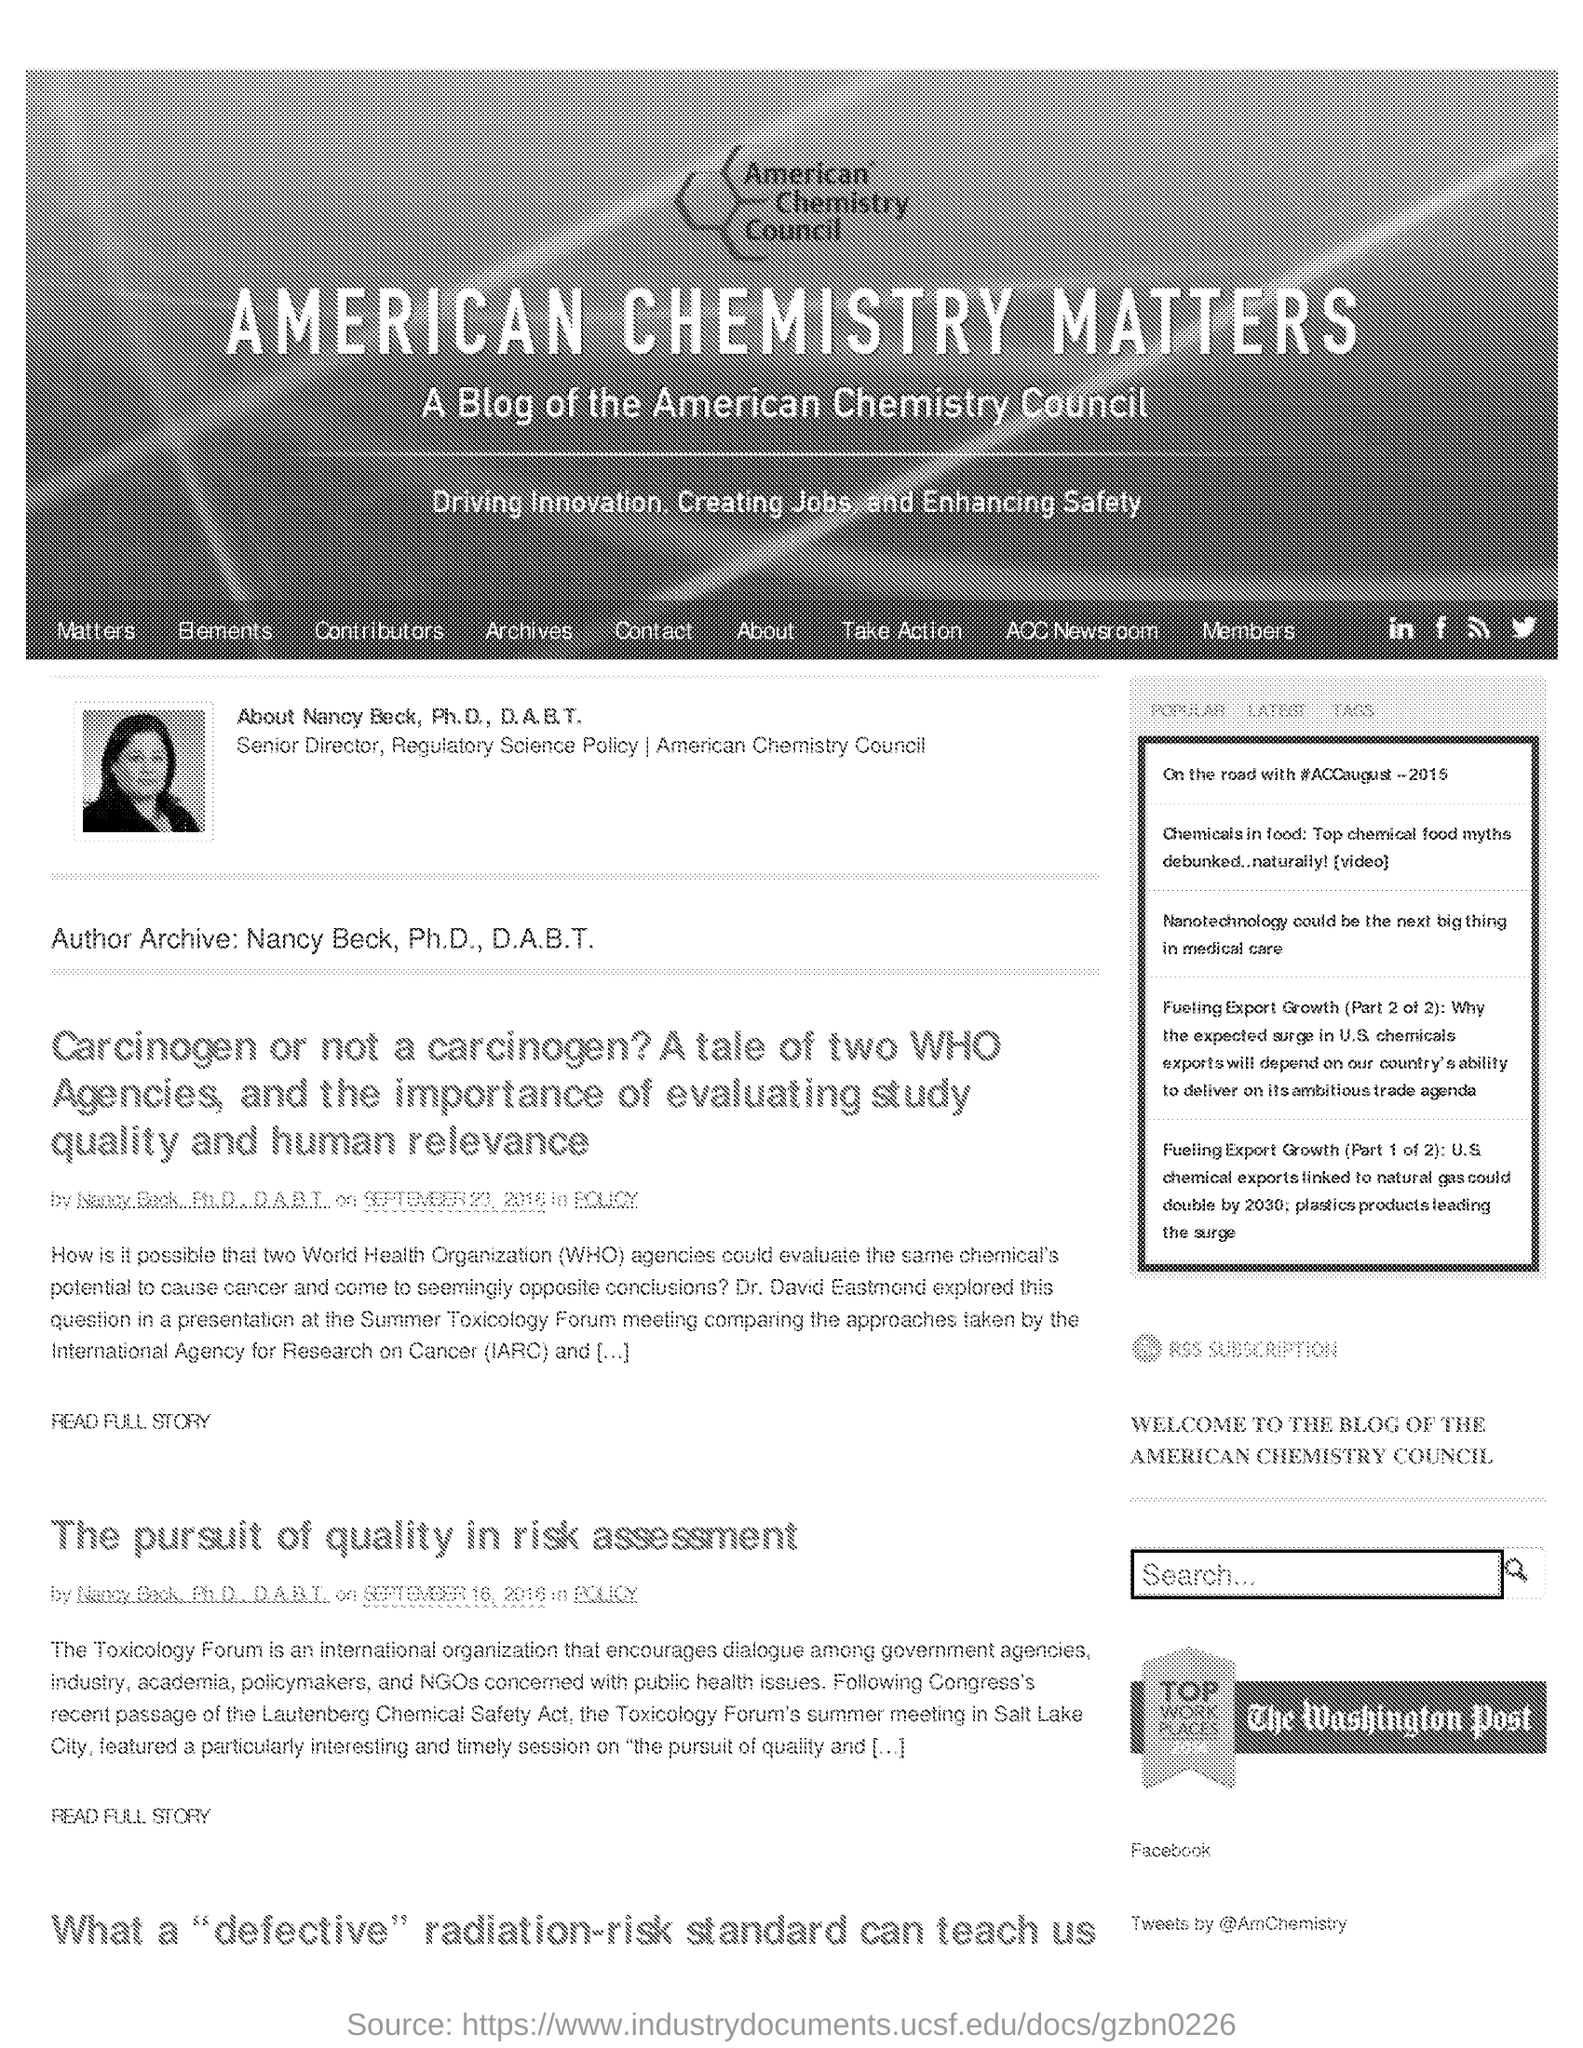Who is the author of the blog page?
Ensure brevity in your answer.  NANCY BECK, PH.D., D.A.B.T. Where was the Toxicology Forum's summer meeting held?
Keep it short and to the point. SALT LAKE CITY. 